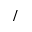Convert formula to latex. <formula><loc_0><loc_0><loc_500><loc_500>/</formula> 